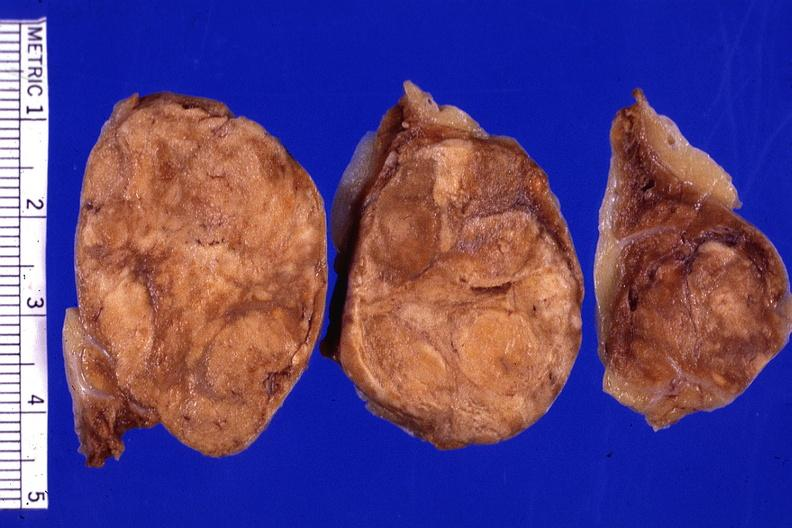what is present?
Answer the question using a single word or phrase. Adrenal 